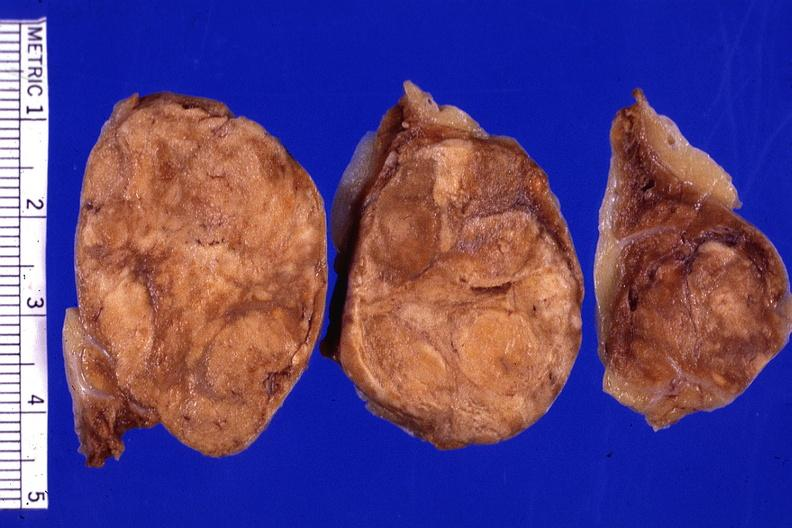what is present?
Answer the question using a single word or phrase. Adrenal 